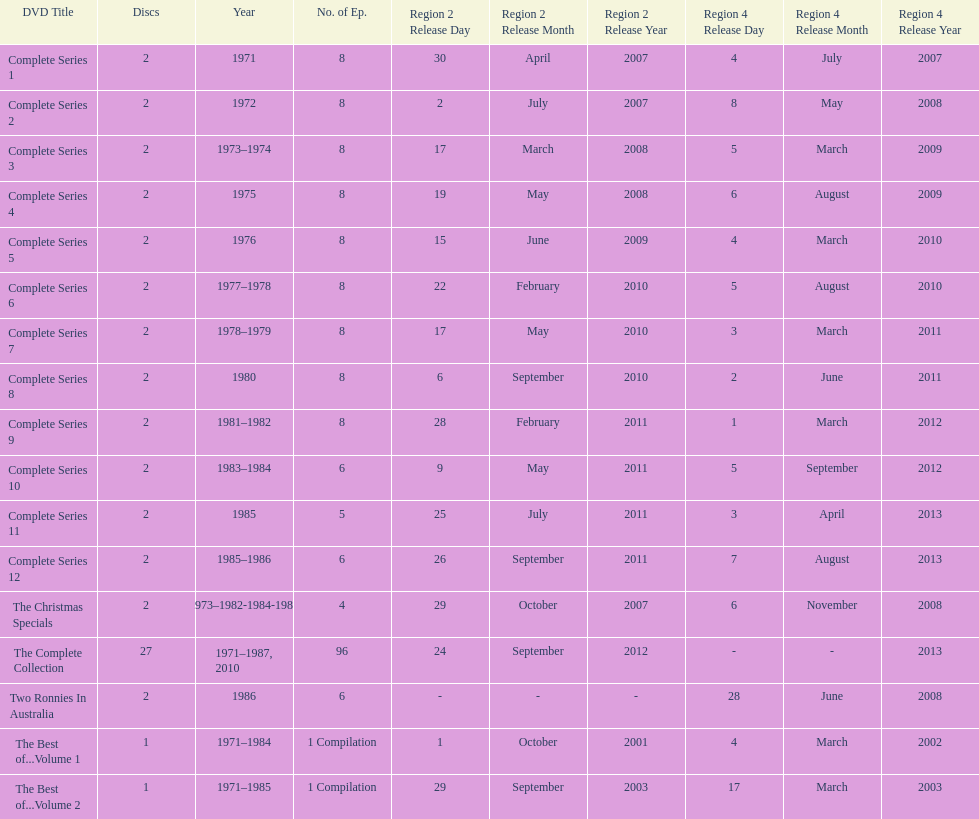Total number of episodes released in region 2 in 2007 20. 